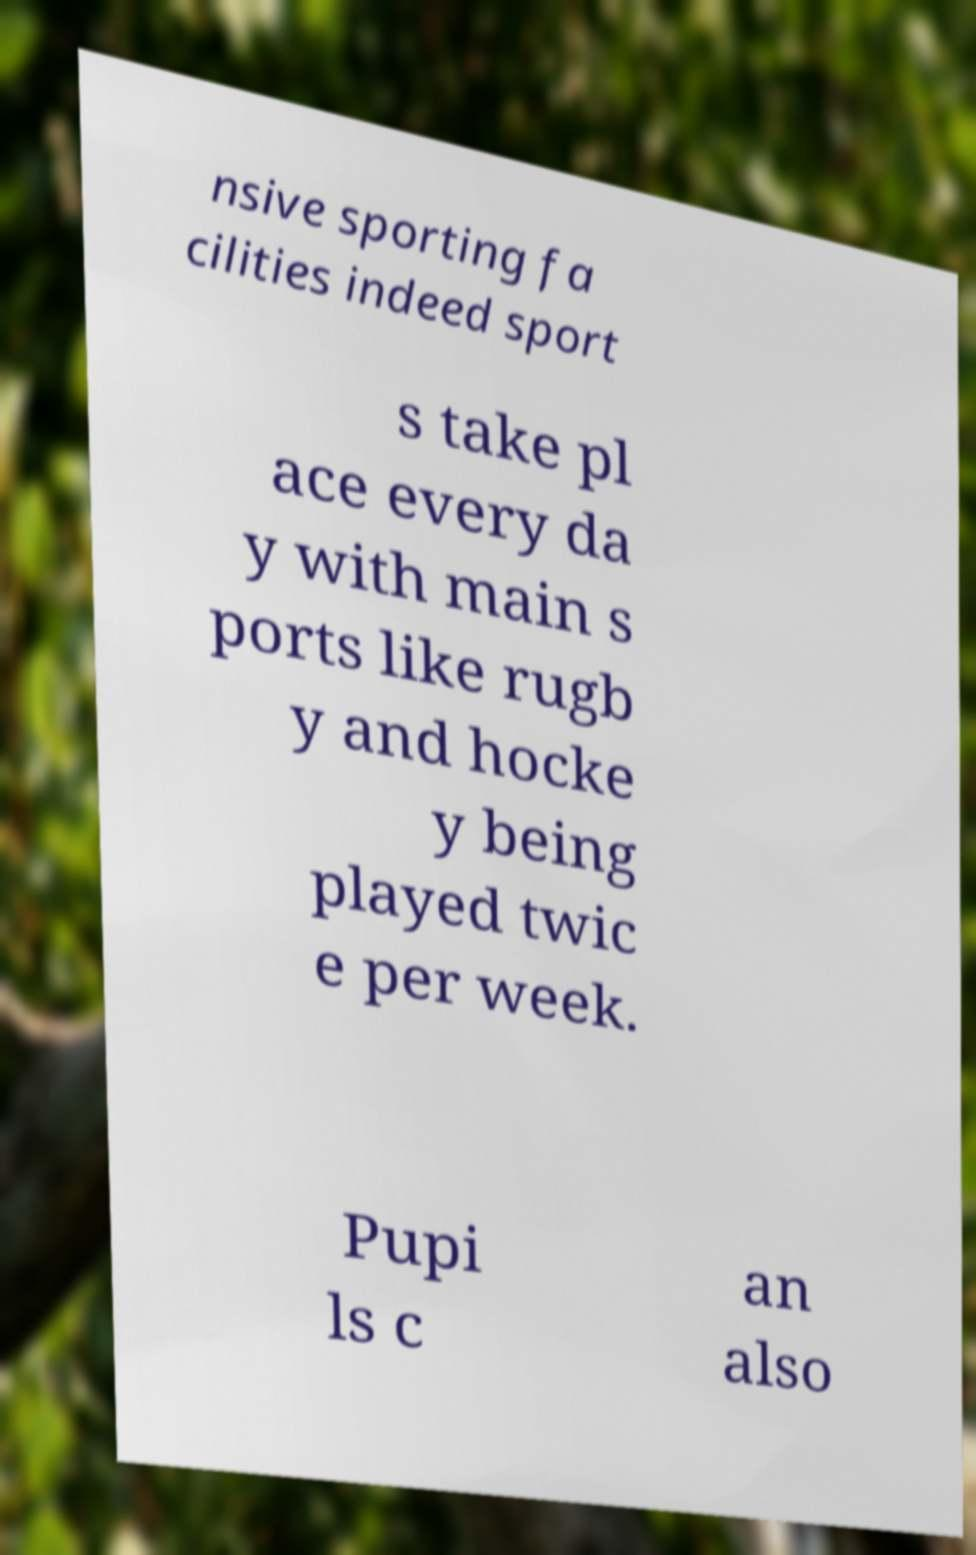Could you assist in decoding the text presented in this image and type it out clearly? nsive sporting fa cilities indeed sport s take pl ace every da y with main s ports like rugb y and hocke y being played twic e per week. Pupi ls c an also 